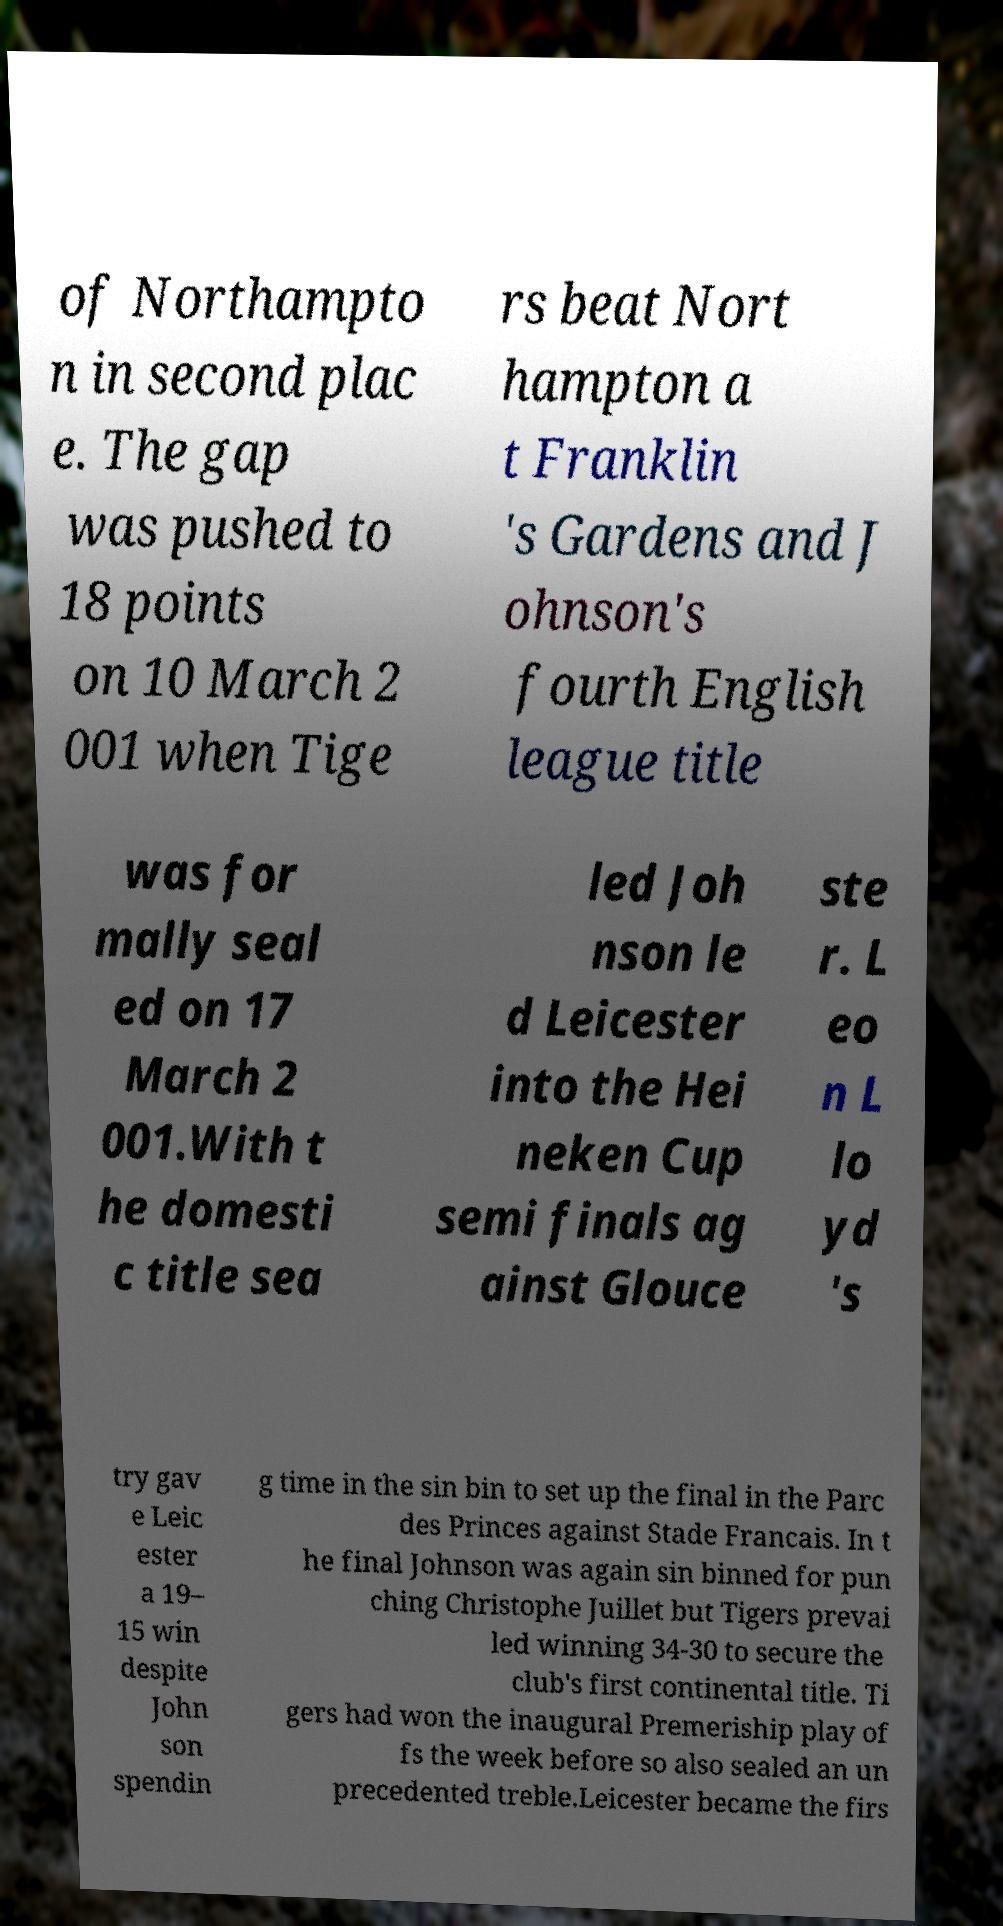Please read and relay the text visible in this image. What does it say? of Northampto n in second plac e. The gap was pushed to 18 points on 10 March 2 001 when Tige rs beat Nort hampton a t Franklin 's Gardens and J ohnson's fourth English league title was for mally seal ed on 17 March 2 001.With t he domesti c title sea led Joh nson le d Leicester into the Hei neken Cup semi finals ag ainst Glouce ste r. L eo n L lo yd 's try gav e Leic ester a 19– 15 win despite John son spendin g time in the sin bin to set up the final in the Parc des Princes against Stade Francais. In t he final Johnson was again sin binned for pun ching Christophe Juillet but Tigers prevai led winning 34-30 to secure the club's first continental title. Ti gers had won the inaugural Premeriship play of fs the week before so also sealed an un precedented treble.Leicester became the firs 